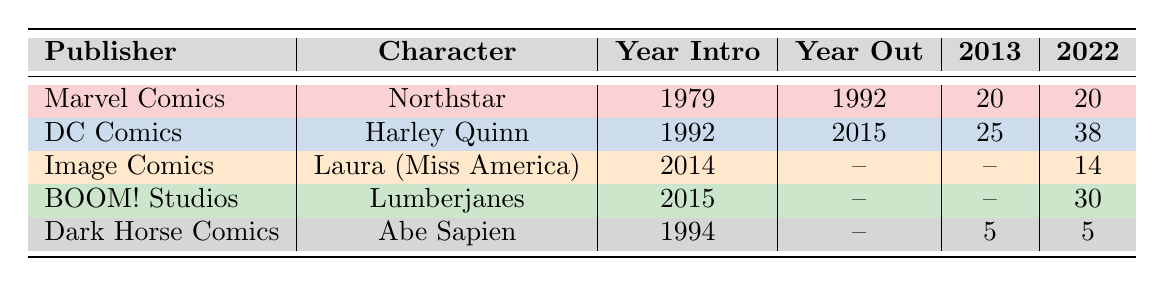What was the first year Northstar appeared in comic books? Northstar, a character from Marvel Comics, was introduced in 1979 as per the table.
Answer: 1979 How many appearances did Harley Quinn have in 2016? According to the table, Harley Quinn had 28 appearances in the year 2016 under DC Comics.
Answer: 28 Which character had the most appearances in 2022? By comparing the 2022 values from the table, Lumberjanes had 30 appearances while Harley Quinn had 38. Hence, Harley Quinn had the most appearances.
Answer: Harley Quinn What is the average number of appearances of Lumberjanes from 2015 to 2023? Summing the appearances from 2015 to 2023: 8 + 10 + 12 + 15 + 18 + 20 + 25 + 30 + 20 = 138. The number of years involved is 9, so 138/9 = 15.33, which we can round down to 15 for simplicity.
Answer: 15 Does Dark Horse Comics have any LGBTQ+ character who has been officially out? Abe Sapien, the character listed under Dark Horse Comics, has not been listed as officially out according to the table, hence the answer is no.
Answer: No Which publisher's character had the least number of appearances in 2020? The appearances in 2020 were 11 for Northstar, 29 for Harley Quinn, 10 for Miss America, 20 for Lumberjanes, and 3 for Abe Sapien. Thus, Abe Sapien had the least number of appearances.
Answer: Dark Horse Comics What was the change in Harley Quinn's appearances from 2013 to 2022? In the table, Harley Quinn had 25 appearances in 2013 and 38 in 2022. The difference is calculated as 38 - 25 = 13.
Answer: 13 How many publishers featured characters introduced after 2010? From the data, Image Comics (2014), BOOM! Studios (2015), and Dark Horse Comics (1994) had characters introduced after 2010. That's 3 publishers: Image Comics, BOOM! Studios, and Dark Horse Comics.
Answer: 3 What was the significance of Laura (Miss America)? According to the table, Laura’s significance is representing bisexuality and being part of a diverse cast in Image Comics.
Answer: Representation of bisexuality and diverse cast 